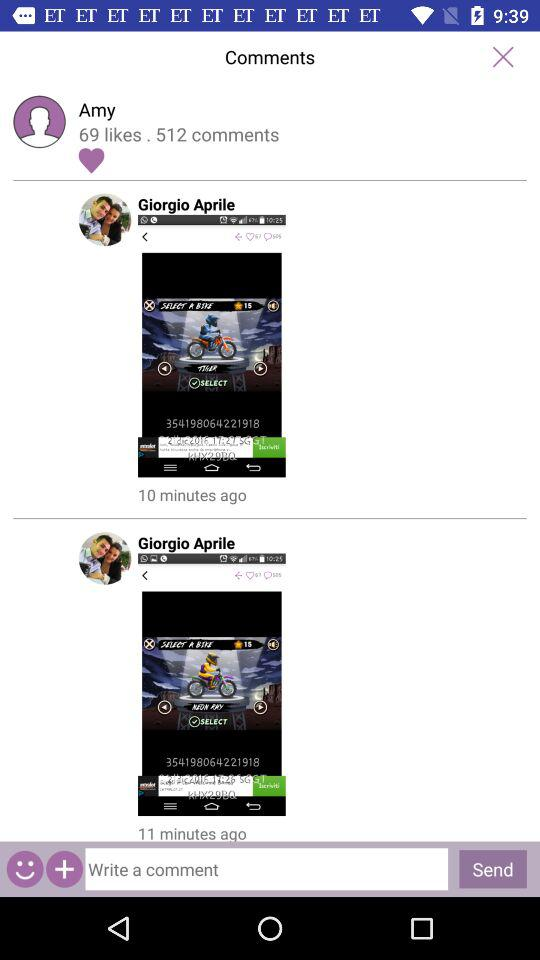How many likes are there? There are 69 likes. 